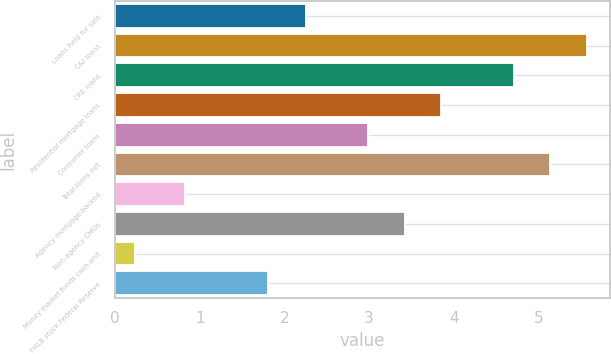Convert chart. <chart><loc_0><loc_0><loc_500><loc_500><bar_chart><fcel>Loans held for sale<fcel>C&I loans<fcel>CRE loans<fcel>Residential mortgage loans<fcel>Consumer loans<fcel>Total loans net<fcel>Agency mortgage-backed<fcel>Non-agency CMOs<fcel>Money market funds cash and<fcel>FHLB stock Federal Reserve<nl><fcel>2.25<fcel>5.57<fcel>4.71<fcel>3.85<fcel>2.99<fcel>5.14<fcel>0.83<fcel>3.42<fcel>0.24<fcel>1.81<nl></chart> 